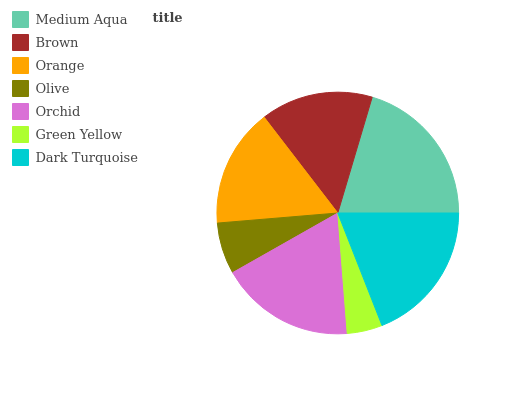Is Green Yellow the minimum?
Answer yes or no. Yes. Is Medium Aqua the maximum?
Answer yes or no. Yes. Is Brown the minimum?
Answer yes or no. No. Is Brown the maximum?
Answer yes or no. No. Is Medium Aqua greater than Brown?
Answer yes or no. Yes. Is Brown less than Medium Aqua?
Answer yes or no. Yes. Is Brown greater than Medium Aqua?
Answer yes or no. No. Is Medium Aqua less than Brown?
Answer yes or no. No. Is Orange the high median?
Answer yes or no. Yes. Is Orange the low median?
Answer yes or no. Yes. Is Dark Turquoise the high median?
Answer yes or no. No. Is Green Yellow the low median?
Answer yes or no. No. 